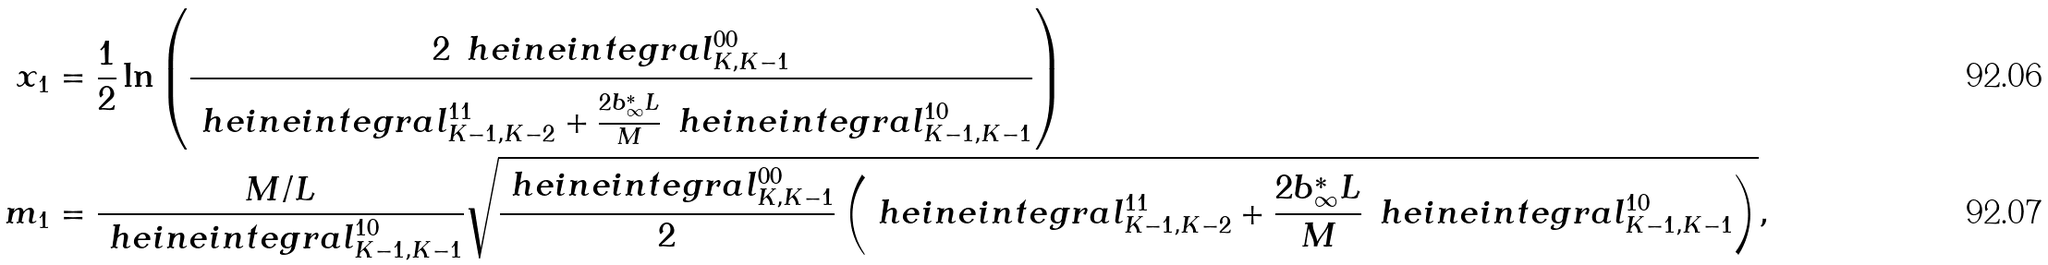Convert formula to latex. <formula><loc_0><loc_0><loc_500><loc_500>x _ { 1 } & = \frac { 1 } { 2 } \ln \left ( \frac { 2 \, \ h e i n e i n t e g r a l _ { K , K - 1 } ^ { 0 0 } } { \ h e i n e i n t e g r a l _ { K - 1 , K - 2 } ^ { 1 1 } + \frac { \strut 2 b ^ { * } _ { \infty } L } { M } \, \ h e i n e i n t e g r a l _ { K - 1 , K - 1 } ^ { 1 0 } } \right ) \\ m _ { 1 } & = \frac { M / L } { \ h e i n e i n t e g r a l _ { K - 1 , K - 1 } ^ { 1 0 } } \sqrt { \frac { \ h e i n e i n t e g r a l _ { K , K - 1 } ^ { 0 0 } } { 2 } \left ( \ h e i n e i n t e g r a l _ { K - 1 , K - 2 } ^ { 1 1 } + \frac { \strut 2 b ^ { * } _ { \infty } L } { M } \, \ h e i n e i n t e g r a l _ { K - 1 , K - 1 } ^ { 1 0 } \right ) } ,</formula> 